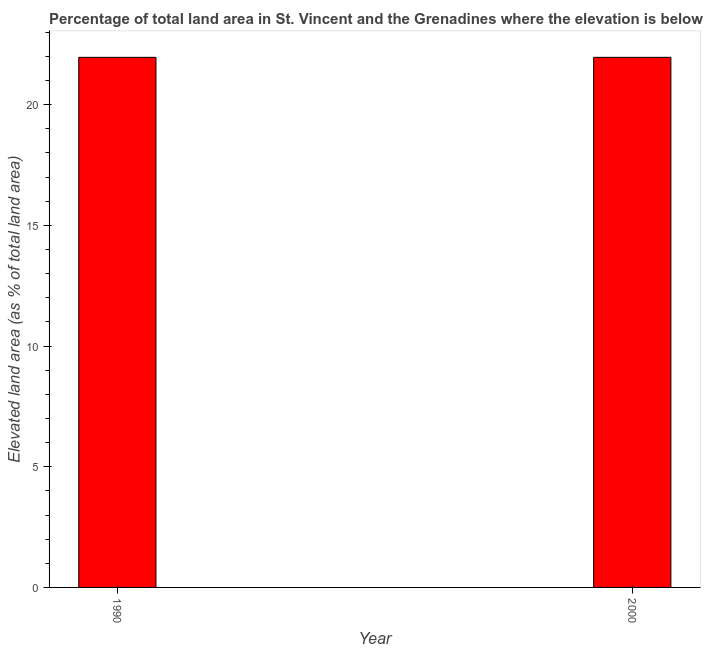Does the graph contain any zero values?
Your answer should be very brief. No. Does the graph contain grids?
Make the answer very short. No. What is the title of the graph?
Your response must be concise. Percentage of total land area in St. Vincent and the Grenadines where the elevation is below 5 meters. What is the label or title of the Y-axis?
Your answer should be very brief. Elevated land area (as % of total land area). What is the total elevated land area in 2000?
Provide a short and direct response. 21.96. Across all years, what is the maximum total elevated land area?
Your answer should be compact. 21.96. Across all years, what is the minimum total elevated land area?
Ensure brevity in your answer.  21.96. What is the sum of the total elevated land area?
Offer a very short reply. 43.92. What is the average total elevated land area per year?
Offer a very short reply. 21.96. What is the median total elevated land area?
Keep it short and to the point. 21.96. Is the total elevated land area in 1990 less than that in 2000?
Your response must be concise. No. In how many years, is the total elevated land area greater than the average total elevated land area taken over all years?
Ensure brevity in your answer.  0. How many years are there in the graph?
Provide a succinct answer. 2. What is the difference between two consecutive major ticks on the Y-axis?
Your answer should be very brief. 5. Are the values on the major ticks of Y-axis written in scientific E-notation?
Provide a short and direct response. No. What is the Elevated land area (as % of total land area) in 1990?
Ensure brevity in your answer.  21.96. What is the Elevated land area (as % of total land area) of 2000?
Make the answer very short. 21.96. What is the difference between the Elevated land area (as % of total land area) in 1990 and 2000?
Give a very brief answer. 0. 